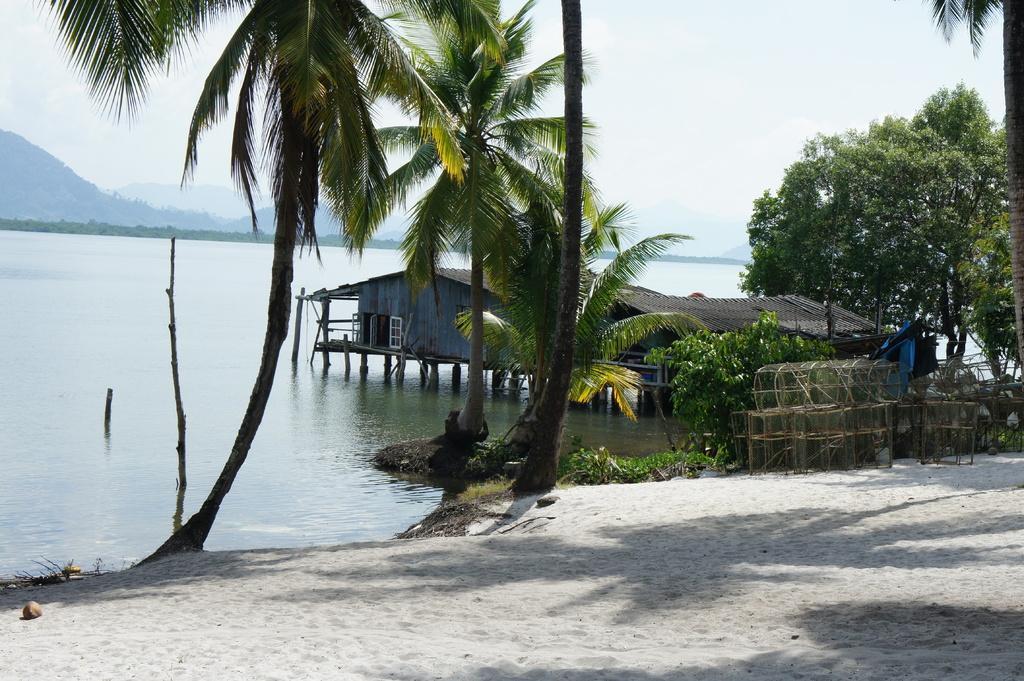Please provide a concise description of this image. In this picture we can see wooden shed and hut on the water. On the right we can see some steel boxes, beside that we can see trees and plants. In the background we can see the mountains. On the right we can see the river. In the top right we can see sky and clouds. At the bottom we can see the sand and coconut. 